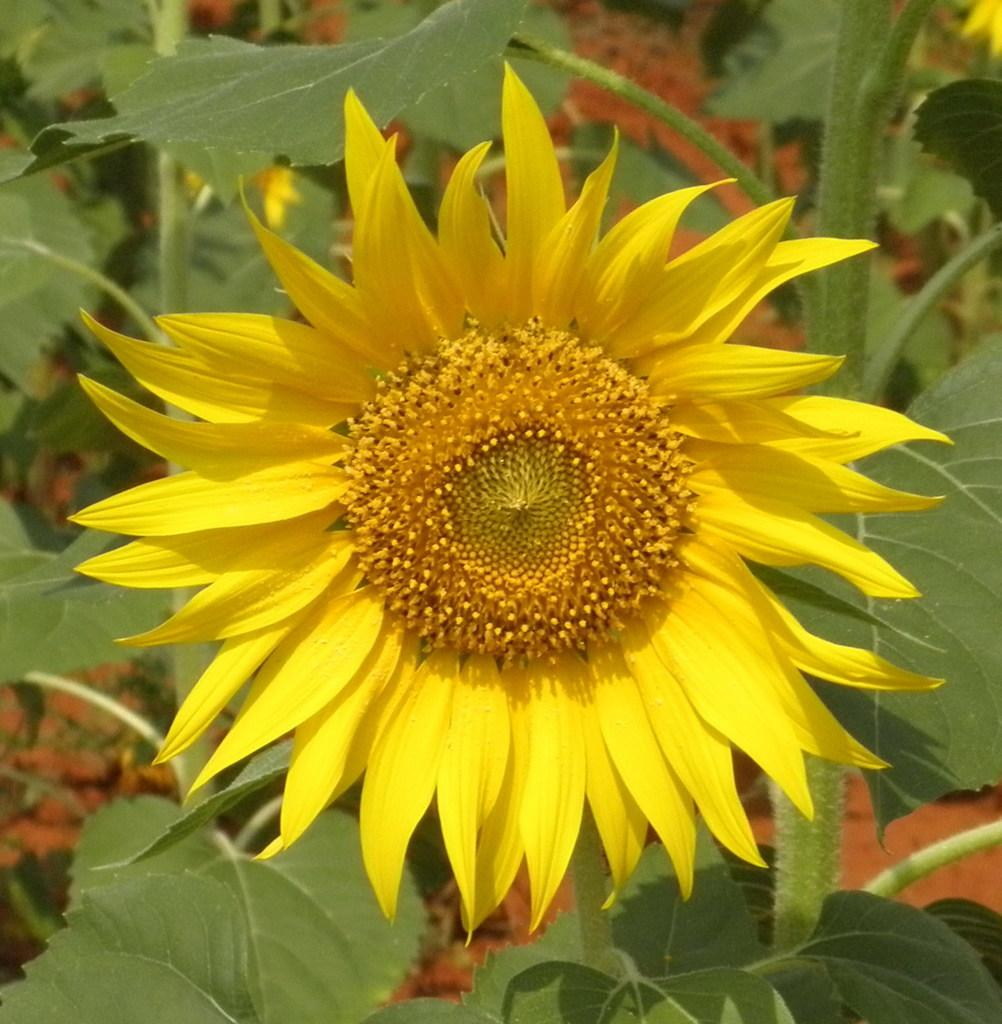What type of plant is the main subject of the image? There is a sunflower in the image. Are there any other plants visible in the image? Yes, there are other plants in the image. What type of club can be seen in the image? There is no club present in the image; it features a sunflower and other plants. How many toes are visible on the sunflower in the image? Sunflowers do not have toes, as they are plants and not animals. 